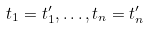Convert formula to latex. <formula><loc_0><loc_0><loc_500><loc_500>t _ { 1 } = t _ { 1 } ^ { \prime } , \dots , t _ { n } = t _ { n } ^ { \prime }</formula> 